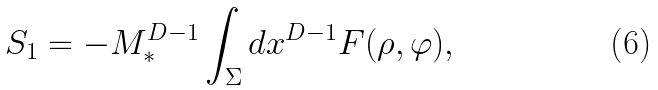Convert formula to latex. <formula><loc_0><loc_0><loc_500><loc_500>S _ { 1 } = - M _ { * } ^ { D - 1 } \int _ { \Sigma } d x ^ { D - 1 } F ( \rho , \varphi ) ,</formula> 